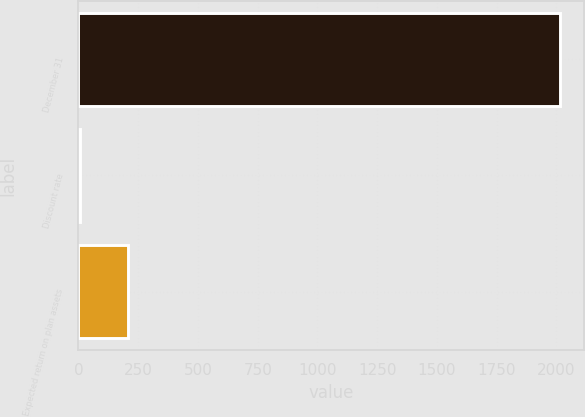Convert chart to OTSL. <chart><loc_0><loc_0><loc_500><loc_500><bar_chart><fcel>December 31<fcel>Discount rate<fcel>Expected return on plan assets<nl><fcel>2016<fcel>4.7<fcel>205.83<nl></chart> 